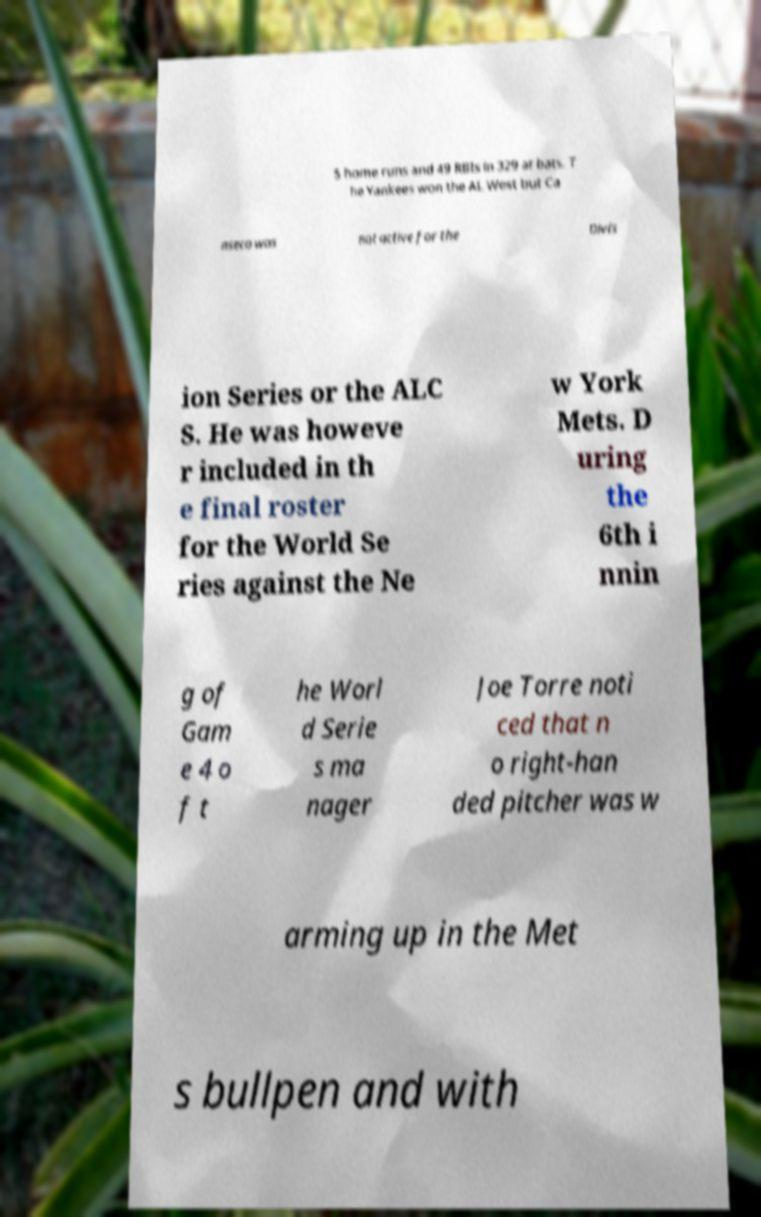Please read and relay the text visible in this image. What does it say? 5 home runs and 49 RBIs in 329 at bats. T he Yankees won the AL West but Ca nseco was not active for the Divis ion Series or the ALC S. He was howeve r included in th e final roster for the World Se ries against the Ne w York Mets. D uring the 6th i nnin g of Gam e 4 o f t he Worl d Serie s ma nager Joe Torre noti ced that n o right-han ded pitcher was w arming up in the Met s bullpen and with 